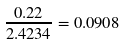Convert formula to latex. <formula><loc_0><loc_0><loc_500><loc_500>\frac { 0 . 2 2 } { 2 . 4 2 3 4 } = 0 . 0 9 0 8</formula> 